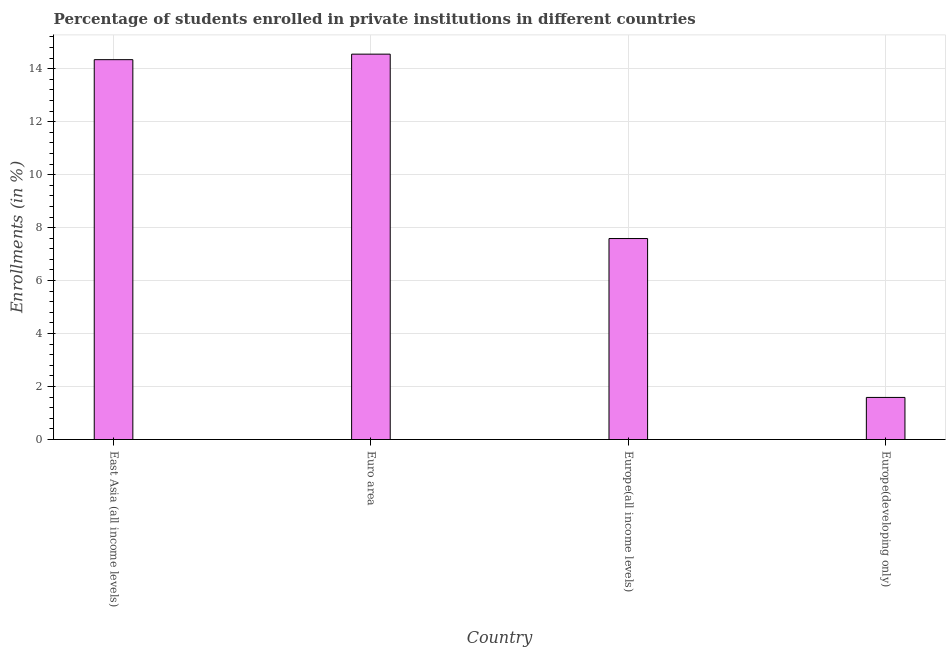Does the graph contain grids?
Keep it short and to the point. Yes. What is the title of the graph?
Your answer should be compact. Percentage of students enrolled in private institutions in different countries. What is the label or title of the Y-axis?
Make the answer very short. Enrollments (in %). What is the enrollments in private institutions in East Asia (all income levels)?
Provide a short and direct response. 14.34. Across all countries, what is the maximum enrollments in private institutions?
Give a very brief answer. 14.55. Across all countries, what is the minimum enrollments in private institutions?
Offer a very short reply. 1.59. In which country was the enrollments in private institutions maximum?
Provide a short and direct response. Euro area. In which country was the enrollments in private institutions minimum?
Your answer should be compact. Europe(developing only). What is the sum of the enrollments in private institutions?
Your answer should be compact. 38.07. What is the difference between the enrollments in private institutions in East Asia (all income levels) and Europe(all income levels)?
Provide a succinct answer. 6.75. What is the average enrollments in private institutions per country?
Give a very brief answer. 9.52. What is the median enrollments in private institutions?
Offer a terse response. 10.96. In how many countries, is the enrollments in private institutions greater than 14.8 %?
Your response must be concise. 0. What is the ratio of the enrollments in private institutions in East Asia (all income levels) to that in Europe(all income levels)?
Offer a very short reply. 1.89. What is the difference between the highest and the second highest enrollments in private institutions?
Provide a succinct answer. 0.21. Is the sum of the enrollments in private institutions in East Asia (all income levels) and Europe(all income levels) greater than the maximum enrollments in private institutions across all countries?
Provide a short and direct response. Yes. What is the difference between the highest and the lowest enrollments in private institutions?
Make the answer very short. 12.96. How many countries are there in the graph?
Your response must be concise. 4. What is the difference between two consecutive major ticks on the Y-axis?
Keep it short and to the point. 2. What is the Enrollments (in %) in East Asia (all income levels)?
Offer a very short reply. 14.34. What is the Enrollments (in %) of Euro area?
Keep it short and to the point. 14.55. What is the Enrollments (in %) in Europe(all income levels)?
Make the answer very short. 7.59. What is the Enrollments (in %) in Europe(developing only)?
Give a very brief answer. 1.59. What is the difference between the Enrollments (in %) in East Asia (all income levels) and Euro area?
Your answer should be very brief. -0.21. What is the difference between the Enrollments (in %) in East Asia (all income levels) and Europe(all income levels)?
Offer a very short reply. 6.75. What is the difference between the Enrollments (in %) in East Asia (all income levels) and Europe(developing only)?
Offer a very short reply. 12.75. What is the difference between the Enrollments (in %) in Euro area and Europe(all income levels)?
Offer a terse response. 6.96. What is the difference between the Enrollments (in %) in Euro area and Europe(developing only)?
Your response must be concise. 12.96. What is the difference between the Enrollments (in %) in Europe(all income levels) and Europe(developing only)?
Keep it short and to the point. 6. What is the ratio of the Enrollments (in %) in East Asia (all income levels) to that in Euro area?
Offer a terse response. 0.99. What is the ratio of the Enrollments (in %) in East Asia (all income levels) to that in Europe(all income levels)?
Keep it short and to the point. 1.89. What is the ratio of the Enrollments (in %) in East Asia (all income levels) to that in Europe(developing only)?
Make the answer very short. 9.02. What is the ratio of the Enrollments (in %) in Euro area to that in Europe(all income levels)?
Your response must be concise. 1.92. What is the ratio of the Enrollments (in %) in Euro area to that in Europe(developing only)?
Give a very brief answer. 9.15. What is the ratio of the Enrollments (in %) in Europe(all income levels) to that in Europe(developing only)?
Your answer should be very brief. 4.78. 